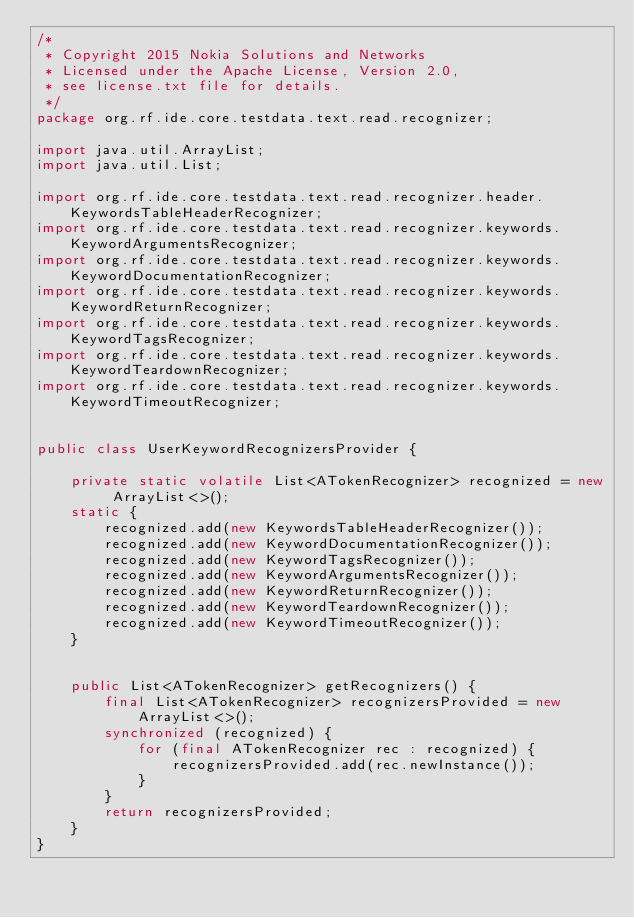<code> <loc_0><loc_0><loc_500><loc_500><_Java_>/*
 * Copyright 2015 Nokia Solutions and Networks
 * Licensed under the Apache License, Version 2.0,
 * see license.txt file for details.
 */
package org.rf.ide.core.testdata.text.read.recognizer;

import java.util.ArrayList;
import java.util.List;

import org.rf.ide.core.testdata.text.read.recognizer.header.KeywordsTableHeaderRecognizer;
import org.rf.ide.core.testdata.text.read.recognizer.keywords.KeywordArgumentsRecognizer;
import org.rf.ide.core.testdata.text.read.recognizer.keywords.KeywordDocumentationRecognizer;
import org.rf.ide.core.testdata.text.read.recognizer.keywords.KeywordReturnRecognizer;
import org.rf.ide.core.testdata.text.read.recognizer.keywords.KeywordTagsRecognizer;
import org.rf.ide.core.testdata.text.read.recognizer.keywords.KeywordTeardownRecognizer;
import org.rf.ide.core.testdata.text.read.recognizer.keywords.KeywordTimeoutRecognizer;


public class UserKeywordRecognizersProvider {

    private static volatile List<ATokenRecognizer> recognized = new ArrayList<>();
    static {
        recognized.add(new KeywordsTableHeaderRecognizer());
        recognized.add(new KeywordDocumentationRecognizer());
        recognized.add(new KeywordTagsRecognizer());
        recognized.add(new KeywordArgumentsRecognizer());
        recognized.add(new KeywordReturnRecognizer());
        recognized.add(new KeywordTeardownRecognizer());
        recognized.add(new KeywordTimeoutRecognizer());
    }


    public List<ATokenRecognizer> getRecognizers() {
        final List<ATokenRecognizer> recognizersProvided = new ArrayList<>();
        synchronized (recognized) {
            for (final ATokenRecognizer rec : recognized) {
                recognizersProvided.add(rec.newInstance());
            }
        }
        return recognizersProvided;
    }
}
</code> 